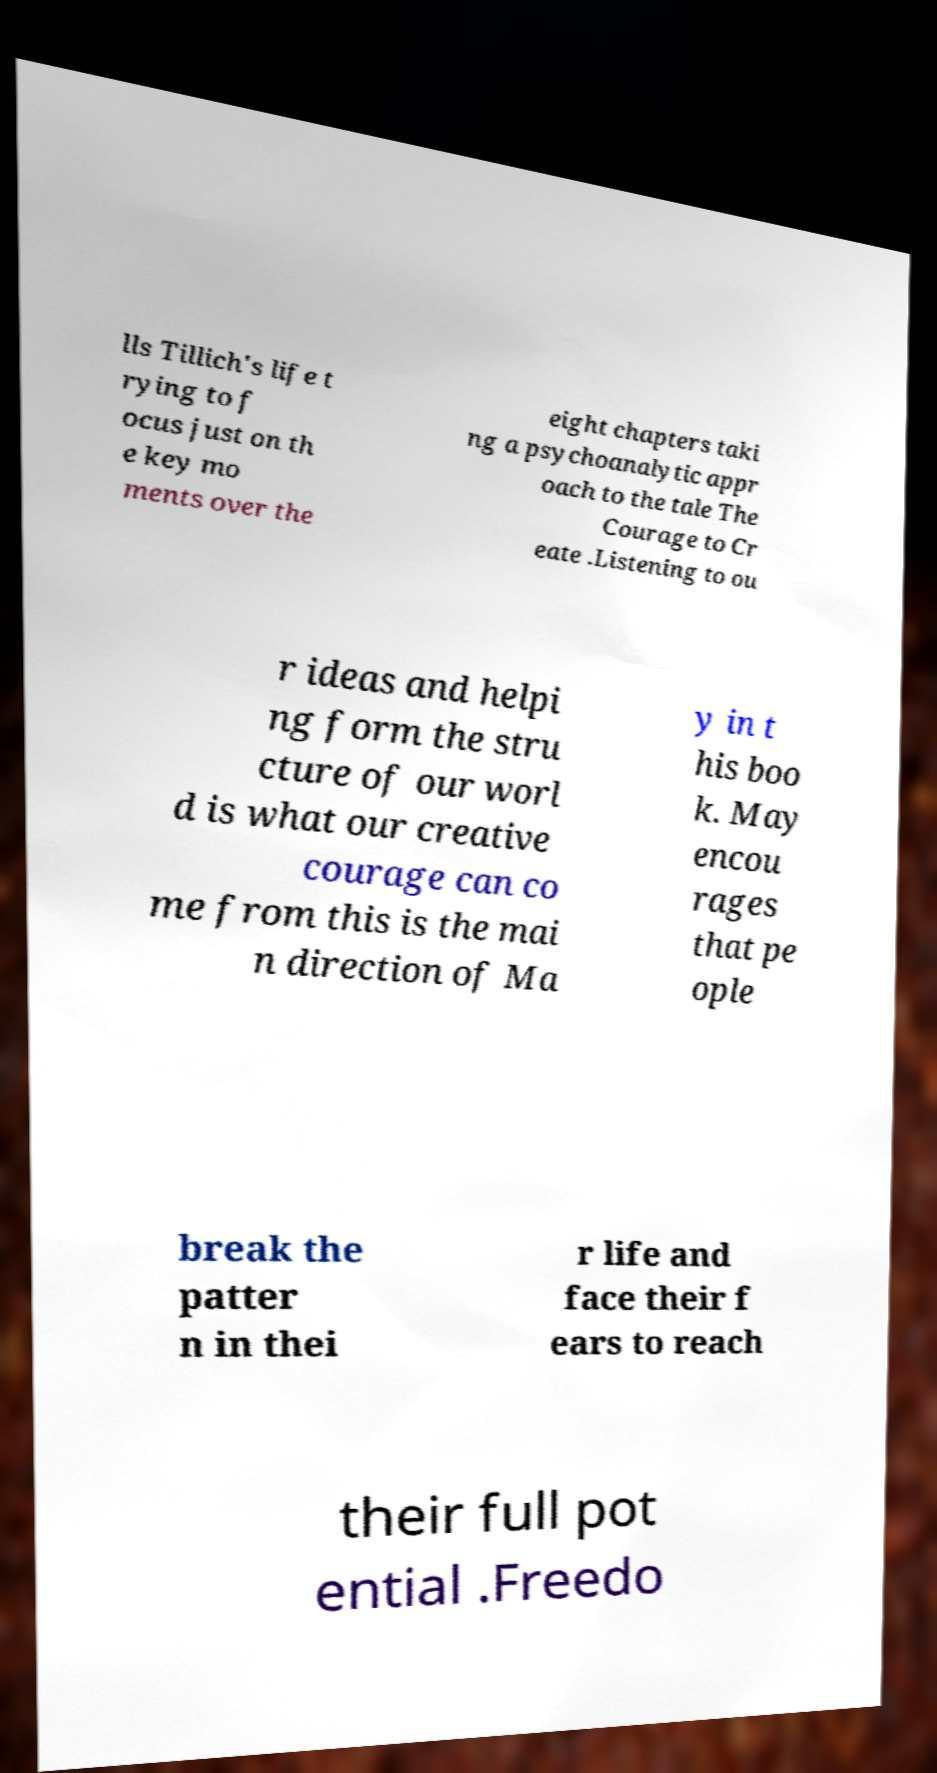Can you accurately transcribe the text from the provided image for me? lls Tillich's life t rying to f ocus just on th e key mo ments over the eight chapters taki ng a psychoanalytic appr oach to the tale The Courage to Cr eate .Listening to ou r ideas and helpi ng form the stru cture of our worl d is what our creative courage can co me from this is the mai n direction of Ma y in t his boo k. May encou rages that pe ople break the patter n in thei r life and face their f ears to reach their full pot ential .Freedo 